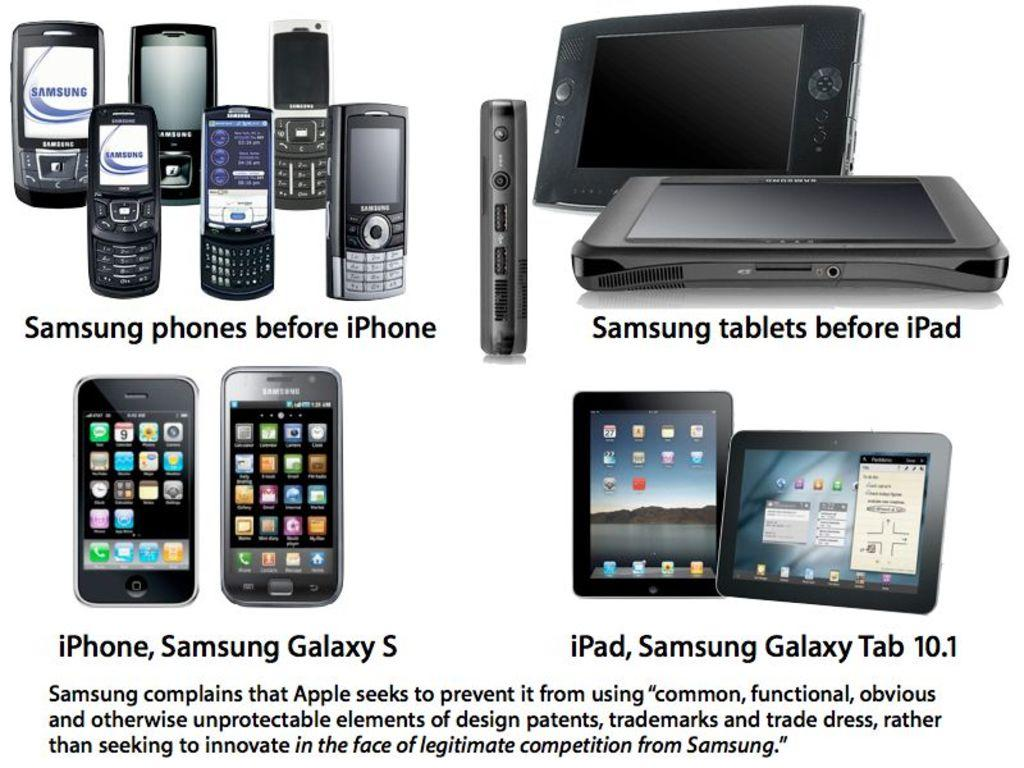<image>
Provide a brief description of the given image. a graphic showing six samsung phones, two samsung tablets, an iphone with a samsung galaxy 5, and ipad, samsung galaxy tab 10.1 